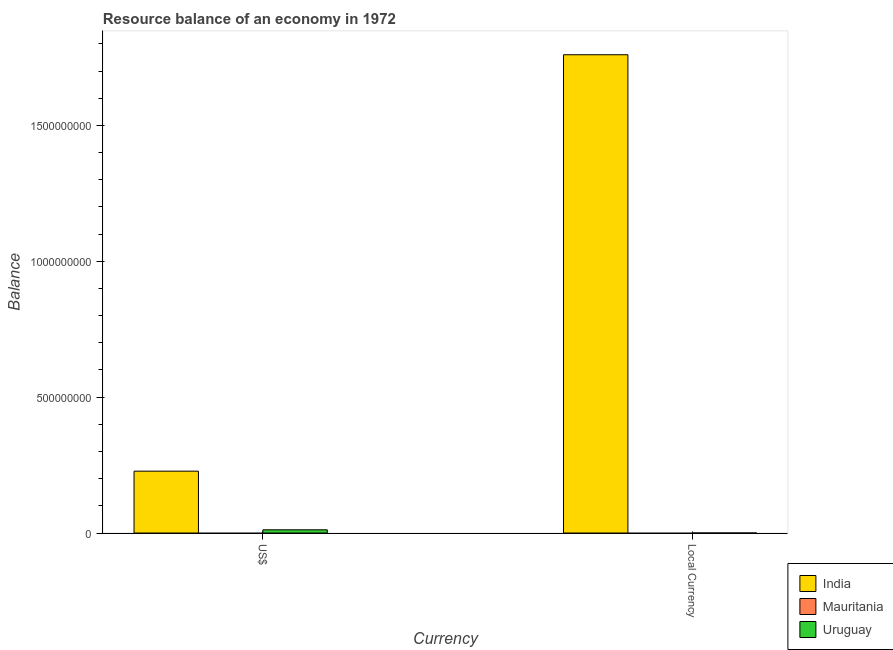How many different coloured bars are there?
Your answer should be compact. 2. Are the number of bars on each tick of the X-axis equal?
Provide a short and direct response. Yes. How many bars are there on the 2nd tick from the left?
Make the answer very short. 2. What is the label of the 1st group of bars from the left?
Your response must be concise. US$. What is the resource balance in constant us$ in India?
Your answer should be very brief. 1.76e+09. Across all countries, what is the maximum resource balance in us$?
Provide a succinct answer. 2.28e+08. In which country was the resource balance in us$ maximum?
Offer a terse response. India. What is the total resource balance in us$ in the graph?
Provide a short and direct response. 2.40e+08. What is the difference between the resource balance in constant us$ in India and that in Uruguay?
Provide a succinct answer. 1.76e+09. What is the difference between the resource balance in us$ in Mauritania and the resource balance in constant us$ in India?
Your answer should be very brief. -1.76e+09. What is the average resource balance in constant us$ per country?
Offer a terse response. 5.87e+08. What is the difference between the resource balance in us$ and resource balance in constant us$ in India?
Keep it short and to the point. -1.53e+09. In how many countries, is the resource balance in constant us$ greater than 1600000000 units?
Your answer should be very brief. 1. What is the ratio of the resource balance in constant us$ in Uruguay to that in India?
Keep it short and to the point. 3.5795454545454546e-6. Does the graph contain any zero values?
Offer a terse response. Yes. How many legend labels are there?
Your response must be concise. 3. What is the title of the graph?
Provide a succinct answer. Resource balance of an economy in 1972. Does "Albania" appear as one of the legend labels in the graph?
Give a very brief answer. No. What is the label or title of the X-axis?
Offer a very short reply. Currency. What is the label or title of the Y-axis?
Provide a short and direct response. Balance. What is the Balance in India in US$?
Your answer should be very brief. 2.28e+08. What is the Balance in Mauritania in US$?
Ensure brevity in your answer.  0. What is the Balance in Uruguay in US$?
Your answer should be compact. 1.19e+07. What is the Balance of India in Local Currency?
Make the answer very short. 1.76e+09. What is the Balance in Mauritania in Local Currency?
Keep it short and to the point. 0. What is the Balance of Uruguay in Local Currency?
Your answer should be compact. 6300. Across all Currency, what is the maximum Balance in India?
Offer a terse response. 1.76e+09. Across all Currency, what is the maximum Balance in Uruguay?
Offer a terse response. 1.19e+07. Across all Currency, what is the minimum Balance in India?
Provide a succinct answer. 2.28e+08. Across all Currency, what is the minimum Balance in Uruguay?
Ensure brevity in your answer.  6300. What is the total Balance of India in the graph?
Make the answer very short. 1.99e+09. What is the total Balance of Uruguay in the graph?
Give a very brief answer. 1.19e+07. What is the difference between the Balance of India in US$ and that in Local Currency?
Make the answer very short. -1.53e+09. What is the difference between the Balance in Uruguay in US$ and that in Local Currency?
Your response must be concise. 1.19e+07. What is the difference between the Balance in India in US$ and the Balance in Uruguay in Local Currency?
Keep it short and to the point. 2.28e+08. What is the average Balance of India per Currency?
Provide a short and direct response. 9.94e+08. What is the average Balance in Mauritania per Currency?
Ensure brevity in your answer.  0. What is the average Balance in Uruguay per Currency?
Ensure brevity in your answer.  5.94e+06. What is the difference between the Balance in India and Balance in Uruguay in US$?
Your answer should be compact. 2.16e+08. What is the difference between the Balance of India and Balance of Uruguay in Local Currency?
Your answer should be compact. 1.76e+09. What is the ratio of the Balance in India in US$ to that in Local Currency?
Your answer should be compact. 0.13. What is the ratio of the Balance in Uruguay in US$ to that in Local Currency?
Make the answer very short. 1883.86. What is the difference between the highest and the second highest Balance of India?
Offer a terse response. 1.53e+09. What is the difference between the highest and the second highest Balance of Uruguay?
Provide a succinct answer. 1.19e+07. What is the difference between the highest and the lowest Balance in India?
Give a very brief answer. 1.53e+09. What is the difference between the highest and the lowest Balance of Uruguay?
Give a very brief answer. 1.19e+07. 